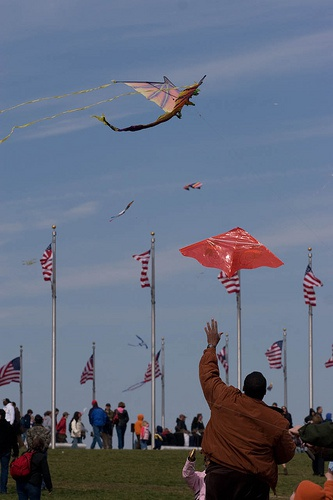Describe the objects in this image and their specific colors. I can see people in gray, black, and maroon tones, people in gray, black, and maroon tones, kite in gray, brown, and salmon tones, people in black, maroon, and gray tones, and kite in gray, darkgray, black, and maroon tones in this image. 